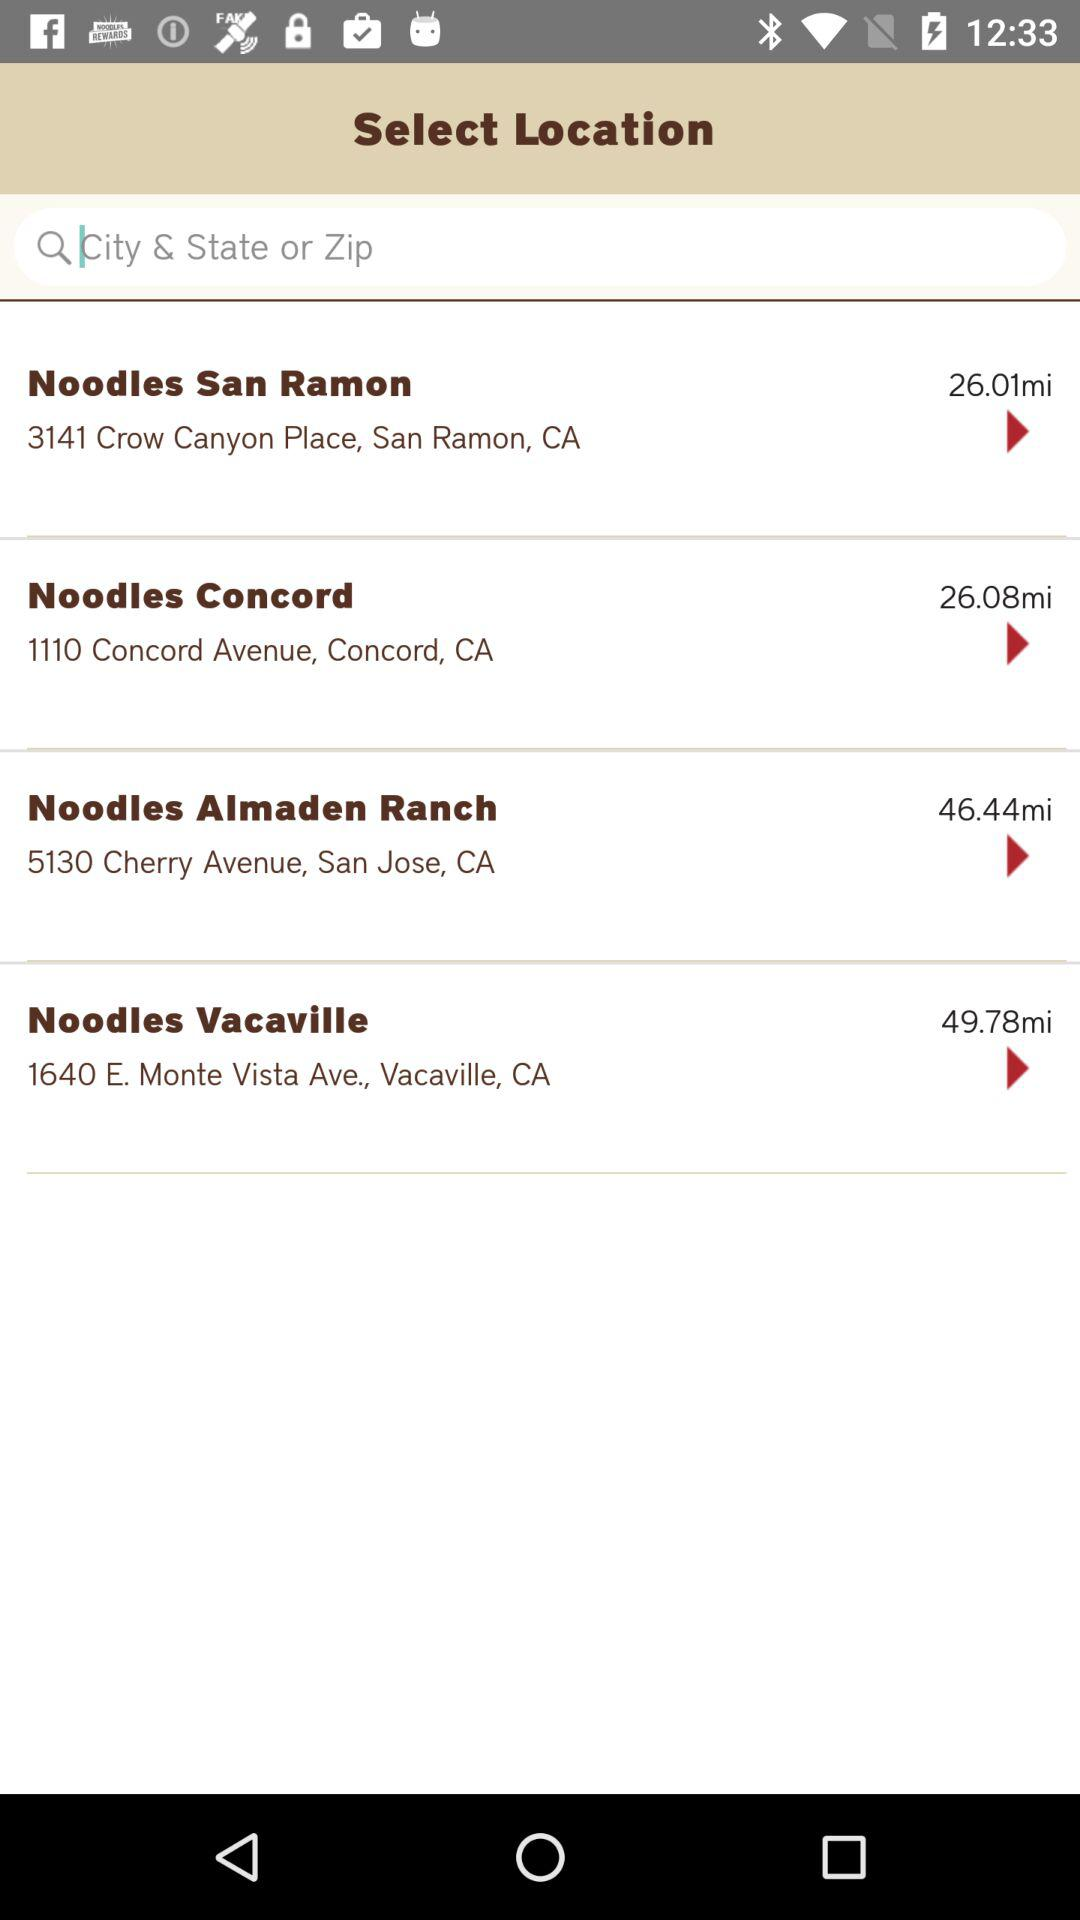What is the address of Noodles San Ramon? The address is 3141 Crow Canyon Place, San Ramon, CA. 